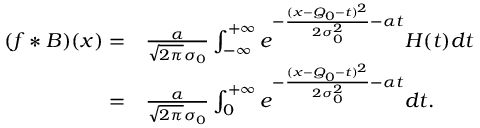Convert formula to latex. <formula><loc_0><loc_0><loc_500><loc_500>\begin{array} { r l } { ( f * B ) ( x ) = } & { \frac { \alpha } { \sqrt { 2 \pi } \sigma _ { 0 } } \int _ { - \infty } ^ { + \infty } e ^ { - \frac { ( x - Q _ { 0 } - t ) ^ { 2 } } { 2 \sigma _ { 0 } ^ { 2 } } - \alpha t } H ( t ) d t } \\ { = } & { \frac { \alpha } { \sqrt { 2 \pi } \sigma _ { 0 } } \int _ { 0 } ^ { + \infty } e ^ { - \frac { ( x - Q _ { 0 } - t ) ^ { 2 } } { 2 \sigma _ { 0 } ^ { 2 } } - \alpha t } d t . } \end{array}</formula> 